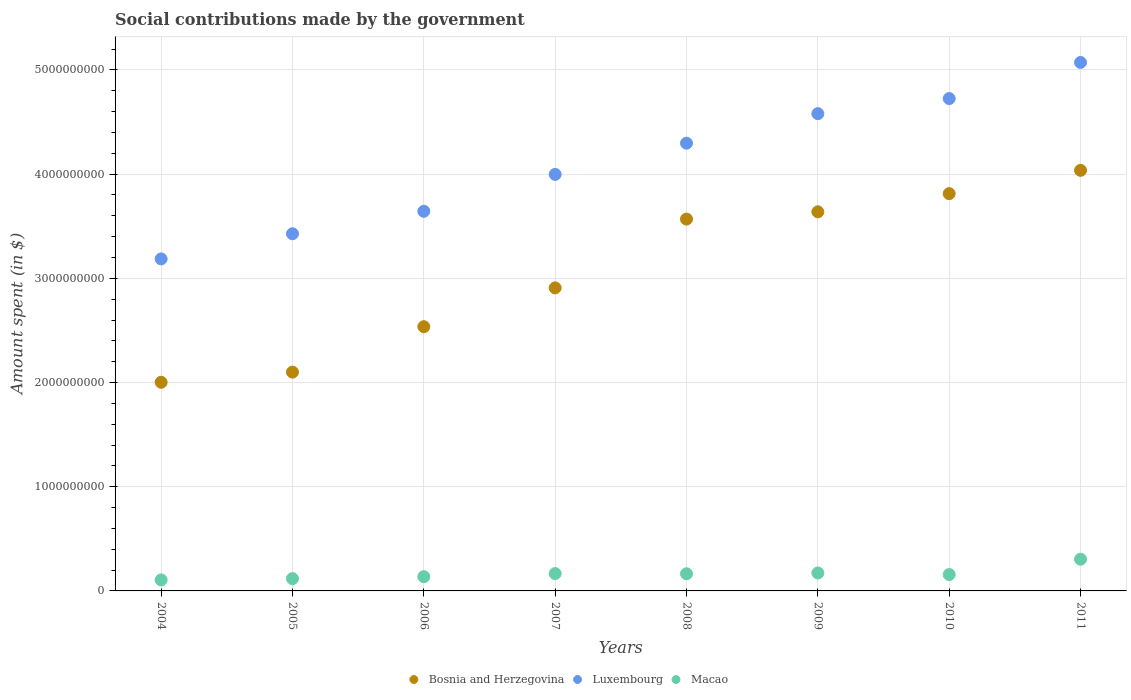Is the number of dotlines equal to the number of legend labels?
Keep it short and to the point. Yes. What is the amount spent on social contributions in Macao in 2011?
Provide a short and direct response. 3.05e+08. Across all years, what is the maximum amount spent on social contributions in Luxembourg?
Give a very brief answer. 5.07e+09. Across all years, what is the minimum amount spent on social contributions in Luxembourg?
Keep it short and to the point. 3.19e+09. In which year was the amount spent on social contributions in Bosnia and Herzegovina minimum?
Ensure brevity in your answer.  2004. What is the total amount spent on social contributions in Bosnia and Herzegovina in the graph?
Your answer should be compact. 2.46e+1. What is the difference between the amount spent on social contributions in Luxembourg in 2008 and that in 2009?
Your answer should be very brief. -2.83e+08. What is the difference between the amount spent on social contributions in Luxembourg in 2004 and the amount spent on social contributions in Macao in 2008?
Offer a terse response. 3.02e+09. What is the average amount spent on social contributions in Macao per year?
Your answer should be very brief. 1.66e+08. In the year 2004, what is the difference between the amount spent on social contributions in Macao and amount spent on social contributions in Luxembourg?
Provide a succinct answer. -3.08e+09. In how many years, is the amount spent on social contributions in Macao greater than 4000000000 $?
Provide a short and direct response. 0. What is the ratio of the amount spent on social contributions in Macao in 2007 to that in 2008?
Your response must be concise. 1.01. Is the difference between the amount spent on social contributions in Macao in 2007 and 2011 greater than the difference between the amount spent on social contributions in Luxembourg in 2007 and 2011?
Offer a terse response. Yes. What is the difference between the highest and the second highest amount spent on social contributions in Bosnia and Herzegovina?
Keep it short and to the point. 2.23e+08. What is the difference between the highest and the lowest amount spent on social contributions in Bosnia and Herzegovina?
Offer a terse response. 2.03e+09. Is the sum of the amount spent on social contributions in Bosnia and Herzegovina in 2005 and 2011 greater than the maximum amount spent on social contributions in Luxembourg across all years?
Provide a short and direct response. Yes. Does the amount spent on social contributions in Macao monotonically increase over the years?
Offer a very short reply. No. What is the difference between two consecutive major ticks on the Y-axis?
Keep it short and to the point. 1.00e+09. Are the values on the major ticks of Y-axis written in scientific E-notation?
Offer a terse response. No. Does the graph contain any zero values?
Keep it short and to the point. No. Does the graph contain grids?
Make the answer very short. Yes. How many legend labels are there?
Give a very brief answer. 3. How are the legend labels stacked?
Offer a very short reply. Horizontal. What is the title of the graph?
Give a very brief answer. Social contributions made by the government. What is the label or title of the X-axis?
Provide a short and direct response. Years. What is the label or title of the Y-axis?
Give a very brief answer. Amount spent (in $). What is the Amount spent (in $) of Bosnia and Herzegovina in 2004?
Offer a very short reply. 2.00e+09. What is the Amount spent (in $) in Luxembourg in 2004?
Provide a succinct answer. 3.19e+09. What is the Amount spent (in $) in Macao in 2004?
Provide a short and direct response. 1.06e+08. What is the Amount spent (in $) of Bosnia and Herzegovina in 2005?
Provide a short and direct response. 2.10e+09. What is the Amount spent (in $) of Luxembourg in 2005?
Your answer should be very brief. 3.43e+09. What is the Amount spent (in $) of Macao in 2005?
Give a very brief answer. 1.18e+08. What is the Amount spent (in $) of Bosnia and Herzegovina in 2006?
Make the answer very short. 2.54e+09. What is the Amount spent (in $) of Luxembourg in 2006?
Offer a very short reply. 3.64e+09. What is the Amount spent (in $) of Macao in 2006?
Your response must be concise. 1.37e+08. What is the Amount spent (in $) of Bosnia and Herzegovina in 2007?
Your answer should be very brief. 2.91e+09. What is the Amount spent (in $) of Luxembourg in 2007?
Provide a short and direct response. 4.00e+09. What is the Amount spent (in $) in Macao in 2007?
Offer a terse response. 1.66e+08. What is the Amount spent (in $) of Bosnia and Herzegovina in 2008?
Give a very brief answer. 3.57e+09. What is the Amount spent (in $) of Luxembourg in 2008?
Offer a very short reply. 4.30e+09. What is the Amount spent (in $) in Macao in 2008?
Keep it short and to the point. 1.65e+08. What is the Amount spent (in $) in Bosnia and Herzegovina in 2009?
Keep it short and to the point. 3.64e+09. What is the Amount spent (in $) of Luxembourg in 2009?
Your response must be concise. 4.58e+09. What is the Amount spent (in $) of Macao in 2009?
Ensure brevity in your answer.  1.72e+08. What is the Amount spent (in $) in Bosnia and Herzegovina in 2010?
Ensure brevity in your answer.  3.81e+09. What is the Amount spent (in $) of Luxembourg in 2010?
Your response must be concise. 4.73e+09. What is the Amount spent (in $) of Macao in 2010?
Provide a succinct answer. 1.57e+08. What is the Amount spent (in $) of Bosnia and Herzegovina in 2011?
Your answer should be very brief. 4.04e+09. What is the Amount spent (in $) in Luxembourg in 2011?
Provide a short and direct response. 5.07e+09. What is the Amount spent (in $) of Macao in 2011?
Your answer should be compact. 3.05e+08. Across all years, what is the maximum Amount spent (in $) of Bosnia and Herzegovina?
Your response must be concise. 4.04e+09. Across all years, what is the maximum Amount spent (in $) of Luxembourg?
Offer a terse response. 5.07e+09. Across all years, what is the maximum Amount spent (in $) in Macao?
Give a very brief answer. 3.05e+08. Across all years, what is the minimum Amount spent (in $) of Bosnia and Herzegovina?
Make the answer very short. 2.00e+09. Across all years, what is the minimum Amount spent (in $) of Luxembourg?
Your answer should be compact. 3.19e+09. Across all years, what is the minimum Amount spent (in $) of Macao?
Your answer should be compact. 1.06e+08. What is the total Amount spent (in $) of Bosnia and Herzegovina in the graph?
Offer a very short reply. 2.46e+1. What is the total Amount spent (in $) of Luxembourg in the graph?
Ensure brevity in your answer.  3.29e+1. What is the total Amount spent (in $) of Macao in the graph?
Provide a short and direct response. 1.33e+09. What is the difference between the Amount spent (in $) in Bosnia and Herzegovina in 2004 and that in 2005?
Give a very brief answer. -9.74e+07. What is the difference between the Amount spent (in $) of Luxembourg in 2004 and that in 2005?
Your response must be concise. -2.41e+08. What is the difference between the Amount spent (in $) of Macao in 2004 and that in 2005?
Keep it short and to the point. -1.25e+07. What is the difference between the Amount spent (in $) in Bosnia and Herzegovina in 2004 and that in 2006?
Your response must be concise. -5.34e+08. What is the difference between the Amount spent (in $) in Luxembourg in 2004 and that in 2006?
Offer a very short reply. -4.57e+08. What is the difference between the Amount spent (in $) of Macao in 2004 and that in 2006?
Provide a succinct answer. -3.15e+07. What is the difference between the Amount spent (in $) in Bosnia and Herzegovina in 2004 and that in 2007?
Provide a succinct answer. -9.06e+08. What is the difference between the Amount spent (in $) in Luxembourg in 2004 and that in 2007?
Ensure brevity in your answer.  -8.11e+08. What is the difference between the Amount spent (in $) of Macao in 2004 and that in 2007?
Your answer should be very brief. -6.09e+07. What is the difference between the Amount spent (in $) of Bosnia and Herzegovina in 2004 and that in 2008?
Offer a terse response. -1.57e+09. What is the difference between the Amount spent (in $) in Luxembourg in 2004 and that in 2008?
Provide a succinct answer. -1.11e+09. What is the difference between the Amount spent (in $) of Macao in 2004 and that in 2008?
Give a very brief answer. -5.90e+07. What is the difference between the Amount spent (in $) in Bosnia and Herzegovina in 2004 and that in 2009?
Your answer should be very brief. -1.64e+09. What is the difference between the Amount spent (in $) in Luxembourg in 2004 and that in 2009?
Offer a terse response. -1.39e+09. What is the difference between the Amount spent (in $) in Macao in 2004 and that in 2009?
Provide a succinct answer. -6.66e+07. What is the difference between the Amount spent (in $) of Bosnia and Herzegovina in 2004 and that in 2010?
Offer a terse response. -1.81e+09. What is the difference between the Amount spent (in $) of Luxembourg in 2004 and that in 2010?
Provide a succinct answer. -1.54e+09. What is the difference between the Amount spent (in $) of Macao in 2004 and that in 2010?
Your answer should be compact. -5.16e+07. What is the difference between the Amount spent (in $) in Bosnia and Herzegovina in 2004 and that in 2011?
Your answer should be compact. -2.03e+09. What is the difference between the Amount spent (in $) in Luxembourg in 2004 and that in 2011?
Offer a very short reply. -1.89e+09. What is the difference between the Amount spent (in $) of Macao in 2004 and that in 2011?
Your response must be concise. -1.99e+08. What is the difference between the Amount spent (in $) in Bosnia and Herzegovina in 2005 and that in 2006?
Provide a short and direct response. -4.36e+08. What is the difference between the Amount spent (in $) of Luxembourg in 2005 and that in 2006?
Provide a short and direct response. -2.16e+08. What is the difference between the Amount spent (in $) of Macao in 2005 and that in 2006?
Offer a very short reply. -1.90e+07. What is the difference between the Amount spent (in $) in Bosnia and Herzegovina in 2005 and that in 2007?
Your response must be concise. -8.09e+08. What is the difference between the Amount spent (in $) in Luxembourg in 2005 and that in 2007?
Provide a succinct answer. -5.70e+08. What is the difference between the Amount spent (in $) in Macao in 2005 and that in 2007?
Your answer should be very brief. -4.84e+07. What is the difference between the Amount spent (in $) in Bosnia and Herzegovina in 2005 and that in 2008?
Ensure brevity in your answer.  -1.47e+09. What is the difference between the Amount spent (in $) in Luxembourg in 2005 and that in 2008?
Make the answer very short. -8.69e+08. What is the difference between the Amount spent (in $) in Macao in 2005 and that in 2008?
Provide a succinct answer. -4.65e+07. What is the difference between the Amount spent (in $) in Bosnia and Herzegovina in 2005 and that in 2009?
Offer a terse response. -1.54e+09. What is the difference between the Amount spent (in $) of Luxembourg in 2005 and that in 2009?
Make the answer very short. -1.15e+09. What is the difference between the Amount spent (in $) of Macao in 2005 and that in 2009?
Offer a terse response. -5.42e+07. What is the difference between the Amount spent (in $) in Bosnia and Herzegovina in 2005 and that in 2010?
Keep it short and to the point. -1.71e+09. What is the difference between the Amount spent (in $) of Luxembourg in 2005 and that in 2010?
Provide a succinct answer. -1.30e+09. What is the difference between the Amount spent (in $) in Macao in 2005 and that in 2010?
Your response must be concise. -3.92e+07. What is the difference between the Amount spent (in $) in Bosnia and Herzegovina in 2005 and that in 2011?
Give a very brief answer. -1.94e+09. What is the difference between the Amount spent (in $) of Luxembourg in 2005 and that in 2011?
Give a very brief answer. -1.64e+09. What is the difference between the Amount spent (in $) of Macao in 2005 and that in 2011?
Give a very brief answer. -1.87e+08. What is the difference between the Amount spent (in $) of Bosnia and Herzegovina in 2006 and that in 2007?
Offer a terse response. -3.73e+08. What is the difference between the Amount spent (in $) in Luxembourg in 2006 and that in 2007?
Provide a short and direct response. -3.54e+08. What is the difference between the Amount spent (in $) of Macao in 2006 and that in 2007?
Ensure brevity in your answer.  -2.94e+07. What is the difference between the Amount spent (in $) in Bosnia and Herzegovina in 2006 and that in 2008?
Provide a short and direct response. -1.03e+09. What is the difference between the Amount spent (in $) of Luxembourg in 2006 and that in 2008?
Offer a terse response. -6.53e+08. What is the difference between the Amount spent (in $) in Macao in 2006 and that in 2008?
Your answer should be compact. -2.75e+07. What is the difference between the Amount spent (in $) of Bosnia and Herzegovina in 2006 and that in 2009?
Your answer should be very brief. -1.10e+09. What is the difference between the Amount spent (in $) of Luxembourg in 2006 and that in 2009?
Your answer should be compact. -9.37e+08. What is the difference between the Amount spent (in $) of Macao in 2006 and that in 2009?
Provide a succinct answer. -3.52e+07. What is the difference between the Amount spent (in $) of Bosnia and Herzegovina in 2006 and that in 2010?
Keep it short and to the point. -1.28e+09. What is the difference between the Amount spent (in $) of Luxembourg in 2006 and that in 2010?
Offer a very short reply. -1.08e+09. What is the difference between the Amount spent (in $) of Macao in 2006 and that in 2010?
Offer a very short reply. -2.02e+07. What is the difference between the Amount spent (in $) of Bosnia and Herzegovina in 2006 and that in 2011?
Make the answer very short. -1.50e+09. What is the difference between the Amount spent (in $) in Luxembourg in 2006 and that in 2011?
Make the answer very short. -1.43e+09. What is the difference between the Amount spent (in $) in Macao in 2006 and that in 2011?
Ensure brevity in your answer.  -1.68e+08. What is the difference between the Amount spent (in $) in Bosnia and Herzegovina in 2007 and that in 2008?
Your answer should be very brief. -6.60e+08. What is the difference between the Amount spent (in $) of Luxembourg in 2007 and that in 2008?
Offer a terse response. -2.99e+08. What is the difference between the Amount spent (in $) of Macao in 2007 and that in 2008?
Your response must be concise. 1.84e+06. What is the difference between the Amount spent (in $) in Bosnia and Herzegovina in 2007 and that in 2009?
Offer a very short reply. -7.30e+08. What is the difference between the Amount spent (in $) in Luxembourg in 2007 and that in 2009?
Offer a terse response. -5.83e+08. What is the difference between the Amount spent (in $) of Macao in 2007 and that in 2009?
Provide a short and direct response. -5.79e+06. What is the difference between the Amount spent (in $) in Bosnia and Herzegovina in 2007 and that in 2010?
Provide a short and direct response. -9.04e+08. What is the difference between the Amount spent (in $) of Luxembourg in 2007 and that in 2010?
Provide a short and direct response. -7.28e+08. What is the difference between the Amount spent (in $) in Macao in 2007 and that in 2010?
Your answer should be compact. 9.21e+06. What is the difference between the Amount spent (in $) of Bosnia and Herzegovina in 2007 and that in 2011?
Give a very brief answer. -1.13e+09. What is the difference between the Amount spent (in $) in Luxembourg in 2007 and that in 2011?
Keep it short and to the point. -1.07e+09. What is the difference between the Amount spent (in $) of Macao in 2007 and that in 2011?
Give a very brief answer. -1.38e+08. What is the difference between the Amount spent (in $) of Bosnia and Herzegovina in 2008 and that in 2009?
Your response must be concise. -6.99e+07. What is the difference between the Amount spent (in $) of Luxembourg in 2008 and that in 2009?
Offer a very short reply. -2.83e+08. What is the difference between the Amount spent (in $) of Macao in 2008 and that in 2009?
Make the answer very short. -7.63e+06. What is the difference between the Amount spent (in $) in Bosnia and Herzegovina in 2008 and that in 2010?
Provide a short and direct response. -2.44e+08. What is the difference between the Amount spent (in $) in Luxembourg in 2008 and that in 2010?
Offer a very short reply. -4.28e+08. What is the difference between the Amount spent (in $) of Macao in 2008 and that in 2010?
Keep it short and to the point. 7.37e+06. What is the difference between the Amount spent (in $) of Bosnia and Herzegovina in 2008 and that in 2011?
Your answer should be compact. -4.68e+08. What is the difference between the Amount spent (in $) of Luxembourg in 2008 and that in 2011?
Make the answer very short. -7.75e+08. What is the difference between the Amount spent (in $) of Macao in 2008 and that in 2011?
Keep it short and to the point. -1.40e+08. What is the difference between the Amount spent (in $) of Bosnia and Herzegovina in 2009 and that in 2010?
Offer a terse response. -1.75e+08. What is the difference between the Amount spent (in $) in Luxembourg in 2009 and that in 2010?
Your answer should be very brief. -1.45e+08. What is the difference between the Amount spent (in $) in Macao in 2009 and that in 2010?
Ensure brevity in your answer.  1.50e+07. What is the difference between the Amount spent (in $) of Bosnia and Herzegovina in 2009 and that in 2011?
Give a very brief answer. -3.98e+08. What is the difference between the Amount spent (in $) of Luxembourg in 2009 and that in 2011?
Provide a succinct answer. -4.92e+08. What is the difference between the Amount spent (in $) of Macao in 2009 and that in 2011?
Make the answer very short. -1.32e+08. What is the difference between the Amount spent (in $) of Bosnia and Herzegovina in 2010 and that in 2011?
Provide a short and direct response. -2.23e+08. What is the difference between the Amount spent (in $) in Luxembourg in 2010 and that in 2011?
Make the answer very short. -3.47e+08. What is the difference between the Amount spent (in $) in Macao in 2010 and that in 2011?
Make the answer very short. -1.47e+08. What is the difference between the Amount spent (in $) of Bosnia and Herzegovina in 2004 and the Amount spent (in $) of Luxembourg in 2005?
Provide a succinct answer. -1.43e+09. What is the difference between the Amount spent (in $) in Bosnia and Herzegovina in 2004 and the Amount spent (in $) in Macao in 2005?
Offer a very short reply. 1.88e+09. What is the difference between the Amount spent (in $) of Luxembourg in 2004 and the Amount spent (in $) of Macao in 2005?
Ensure brevity in your answer.  3.07e+09. What is the difference between the Amount spent (in $) of Bosnia and Herzegovina in 2004 and the Amount spent (in $) of Luxembourg in 2006?
Your answer should be compact. -1.64e+09. What is the difference between the Amount spent (in $) of Bosnia and Herzegovina in 2004 and the Amount spent (in $) of Macao in 2006?
Offer a very short reply. 1.87e+09. What is the difference between the Amount spent (in $) of Luxembourg in 2004 and the Amount spent (in $) of Macao in 2006?
Your response must be concise. 3.05e+09. What is the difference between the Amount spent (in $) of Bosnia and Herzegovina in 2004 and the Amount spent (in $) of Luxembourg in 2007?
Your answer should be compact. -2.00e+09. What is the difference between the Amount spent (in $) of Bosnia and Herzegovina in 2004 and the Amount spent (in $) of Macao in 2007?
Your answer should be very brief. 1.84e+09. What is the difference between the Amount spent (in $) in Luxembourg in 2004 and the Amount spent (in $) in Macao in 2007?
Offer a very short reply. 3.02e+09. What is the difference between the Amount spent (in $) in Bosnia and Herzegovina in 2004 and the Amount spent (in $) in Luxembourg in 2008?
Offer a terse response. -2.29e+09. What is the difference between the Amount spent (in $) of Bosnia and Herzegovina in 2004 and the Amount spent (in $) of Macao in 2008?
Provide a succinct answer. 1.84e+09. What is the difference between the Amount spent (in $) in Luxembourg in 2004 and the Amount spent (in $) in Macao in 2008?
Provide a succinct answer. 3.02e+09. What is the difference between the Amount spent (in $) of Bosnia and Herzegovina in 2004 and the Amount spent (in $) of Luxembourg in 2009?
Keep it short and to the point. -2.58e+09. What is the difference between the Amount spent (in $) in Bosnia and Herzegovina in 2004 and the Amount spent (in $) in Macao in 2009?
Your answer should be compact. 1.83e+09. What is the difference between the Amount spent (in $) of Luxembourg in 2004 and the Amount spent (in $) of Macao in 2009?
Your response must be concise. 3.01e+09. What is the difference between the Amount spent (in $) of Bosnia and Herzegovina in 2004 and the Amount spent (in $) of Luxembourg in 2010?
Provide a succinct answer. -2.72e+09. What is the difference between the Amount spent (in $) in Bosnia and Herzegovina in 2004 and the Amount spent (in $) in Macao in 2010?
Ensure brevity in your answer.  1.85e+09. What is the difference between the Amount spent (in $) in Luxembourg in 2004 and the Amount spent (in $) in Macao in 2010?
Offer a terse response. 3.03e+09. What is the difference between the Amount spent (in $) in Bosnia and Herzegovina in 2004 and the Amount spent (in $) in Luxembourg in 2011?
Make the answer very short. -3.07e+09. What is the difference between the Amount spent (in $) in Bosnia and Herzegovina in 2004 and the Amount spent (in $) in Macao in 2011?
Offer a very short reply. 1.70e+09. What is the difference between the Amount spent (in $) of Luxembourg in 2004 and the Amount spent (in $) of Macao in 2011?
Make the answer very short. 2.88e+09. What is the difference between the Amount spent (in $) in Bosnia and Herzegovina in 2005 and the Amount spent (in $) in Luxembourg in 2006?
Make the answer very short. -1.54e+09. What is the difference between the Amount spent (in $) in Bosnia and Herzegovina in 2005 and the Amount spent (in $) in Macao in 2006?
Provide a succinct answer. 1.96e+09. What is the difference between the Amount spent (in $) of Luxembourg in 2005 and the Amount spent (in $) of Macao in 2006?
Your answer should be compact. 3.29e+09. What is the difference between the Amount spent (in $) of Bosnia and Herzegovina in 2005 and the Amount spent (in $) of Luxembourg in 2007?
Provide a short and direct response. -1.90e+09. What is the difference between the Amount spent (in $) of Bosnia and Herzegovina in 2005 and the Amount spent (in $) of Macao in 2007?
Your answer should be very brief. 1.93e+09. What is the difference between the Amount spent (in $) in Luxembourg in 2005 and the Amount spent (in $) in Macao in 2007?
Make the answer very short. 3.26e+09. What is the difference between the Amount spent (in $) in Bosnia and Herzegovina in 2005 and the Amount spent (in $) in Luxembourg in 2008?
Ensure brevity in your answer.  -2.20e+09. What is the difference between the Amount spent (in $) in Bosnia and Herzegovina in 2005 and the Amount spent (in $) in Macao in 2008?
Your answer should be compact. 1.94e+09. What is the difference between the Amount spent (in $) of Luxembourg in 2005 and the Amount spent (in $) of Macao in 2008?
Your answer should be compact. 3.26e+09. What is the difference between the Amount spent (in $) in Bosnia and Herzegovina in 2005 and the Amount spent (in $) in Luxembourg in 2009?
Your answer should be very brief. -2.48e+09. What is the difference between the Amount spent (in $) of Bosnia and Herzegovina in 2005 and the Amount spent (in $) of Macao in 2009?
Provide a succinct answer. 1.93e+09. What is the difference between the Amount spent (in $) of Luxembourg in 2005 and the Amount spent (in $) of Macao in 2009?
Provide a succinct answer. 3.26e+09. What is the difference between the Amount spent (in $) in Bosnia and Herzegovina in 2005 and the Amount spent (in $) in Luxembourg in 2010?
Provide a short and direct response. -2.63e+09. What is the difference between the Amount spent (in $) in Bosnia and Herzegovina in 2005 and the Amount spent (in $) in Macao in 2010?
Ensure brevity in your answer.  1.94e+09. What is the difference between the Amount spent (in $) of Luxembourg in 2005 and the Amount spent (in $) of Macao in 2010?
Offer a terse response. 3.27e+09. What is the difference between the Amount spent (in $) in Bosnia and Herzegovina in 2005 and the Amount spent (in $) in Luxembourg in 2011?
Provide a short and direct response. -2.97e+09. What is the difference between the Amount spent (in $) of Bosnia and Herzegovina in 2005 and the Amount spent (in $) of Macao in 2011?
Give a very brief answer. 1.80e+09. What is the difference between the Amount spent (in $) in Luxembourg in 2005 and the Amount spent (in $) in Macao in 2011?
Offer a terse response. 3.12e+09. What is the difference between the Amount spent (in $) in Bosnia and Herzegovina in 2006 and the Amount spent (in $) in Luxembourg in 2007?
Your answer should be very brief. -1.46e+09. What is the difference between the Amount spent (in $) of Bosnia and Herzegovina in 2006 and the Amount spent (in $) of Macao in 2007?
Offer a very short reply. 2.37e+09. What is the difference between the Amount spent (in $) in Luxembourg in 2006 and the Amount spent (in $) in Macao in 2007?
Ensure brevity in your answer.  3.48e+09. What is the difference between the Amount spent (in $) in Bosnia and Herzegovina in 2006 and the Amount spent (in $) in Luxembourg in 2008?
Provide a succinct answer. -1.76e+09. What is the difference between the Amount spent (in $) in Bosnia and Herzegovina in 2006 and the Amount spent (in $) in Macao in 2008?
Ensure brevity in your answer.  2.37e+09. What is the difference between the Amount spent (in $) of Luxembourg in 2006 and the Amount spent (in $) of Macao in 2008?
Your answer should be compact. 3.48e+09. What is the difference between the Amount spent (in $) of Bosnia and Herzegovina in 2006 and the Amount spent (in $) of Luxembourg in 2009?
Provide a succinct answer. -2.04e+09. What is the difference between the Amount spent (in $) in Bosnia and Herzegovina in 2006 and the Amount spent (in $) in Macao in 2009?
Offer a very short reply. 2.36e+09. What is the difference between the Amount spent (in $) of Luxembourg in 2006 and the Amount spent (in $) of Macao in 2009?
Offer a very short reply. 3.47e+09. What is the difference between the Amount spent (in $) of Bosnia and Herzegovina in 2006 and the Amount spent (in $) of Luxembourg in 2010?
Your answer should be compact. -2.19e+09. What is the difference between the Amount spent (in $) in Bosnia and Herzegovina in 2006 and the Amount spent (in $) in Macao in 2010?
Make the answer very short. 2.38e+09. What is the difference between the Amount spent (in $) in Luxembourg in 2006 and the Amount spent (in $) in Macao in 2010?
Offer a very short reply. 3.49e+09. What is the difference between the Amount spent (in $) of Bosnia and Herzegovina in 2006 and the Amount spent (in $) of Luxembourg in 2011?
Your response must be concise. -2.54e+09. What is the difference between the Amount spent (in $) of Bosnia and Herzegovina in 2006 and the Amount spent (in $) of Macao in 2011?
Give a very brief answer. 2.23e+09. What is the difference between the Amount spent (in $) of Luxembourg in 2006 and the Amount spent (in $) of Macao in 2011?
Offer a terse response. 3.34e+09. What is the difference between the Amount spent (in $) in Bosnia and Herzegovina in 2007 and the Amount spent (in $) in Luxembourg in 2008?
Your answer should be very brief. -1.39e+09. What is the difference between the Amount spent (in $) in Bosnia and Herzegovina in 2007 and the Amount spent (in $) in Macao in 2008?
Provide a short and direct response. 2.74e+09. What is the difference between the Amount spent (in $) of Luxembourg in 2007 and the Amount spent (in $) of Macao in 2008?
Provide a short and direct response. 3.83e+09. What is the difference between the Amount spent (in $) of Bosnia and Herzegovina in 2007 and the Amount spent (in $) of Luxembourg in 2009?
Your answer should be compact. -1.67e+09. What is the difference between the Amount spent (in $) in Bosnia and Herzegovina in 2007 and the Amount spent (in $) in Macao in 2009?
Offer a terse response. 2.74e+09. What is the difference between the Amount spent (in $) in Luxembourg in 2007 and the Amount spent (in $) in Macao in 2009?
Your response must be concise. 3.83e+09. What is the difference between the Amount spent (in $) of Bosnia and Herzegovina in 2007 and the Amount spent (in $) of Luxembourg in 2010?
Keep it short and to the point. -1.82e+09. What is the difference between the Amount spent (in $) in Bosnia and Herzegovina in 2007 and the Amount spent (in $) in Macao in 2010?
Your answer should be very brief. 2.75e+09. What is the difference between the Amount spent (in $) of Luxembourg in 2007 and the Amount spent (in $) of Macao in 2010?
Offer a very short reply. 3.84e+09. What is the difference between the Amount spent (in $) in Bosnia and Herzegovina in 2007 and the Amount spent (in $) in Luxembourg in 2011?
Your response must be concise. -2.16e+09. What is the difference between the Amount spent (in $) of Bosnia and Herzegovina in 2007 and the Amount spent (in $) of Macao in 2011?
Make the answer very short. 2.60e+09. What is the difference between the Amount spent (in $) in Luxembourg in 2007 and the Amount spent (in $) in Macao in 2011?
Keep it short and to the point. 3.69e+09. What is the difference between the Amount spent (in $) of Bosnia and Herzegovina in 2008 and the Amount spent (in $) of Luxembourg in 2009?
Your answer should be very brief. -1.01e+09. What is the difference between the Amount spent (in $) of Bosnia and Herzegovina in 2008 and the Amount spent (in $) of Macao in 2009?
Give a very brief answer. 3.40e+09. What is the difference between the Amount spent (in $) of Luxembourg in 2008 and the Amount spent (in $) of Macao in 2009?
Offer a terse response. 4.12e+09. What is the difference between the Amount spent (in $) of Bosnia and Herzegovina in 2008 and the Amount spent (in $) of Luxembourg in 2010?
Make the answer very short. -1.16e+09. What is the difference between the Amount spent (in $) of Bosnia and Herzegovina in 2008 and the Amount spent (in $) of Macao in 2010?
Your response must be concise. 3.41e+09. What is the difference between the Amount spent (in $) of Luxembourg in 2008 and the Amount spent (in $) of Macao in 2010?
Give a very brief answer. 4.14e+09. What is the difference between the Amount spent (in $) of Bosnia and Herzegovina in 2008 and the Amount spent (in $) of Luxembourg in 2011?
Give a very brief answer. -1.50e+09. What is the difference between the Amount spent (in $) of Bosnia and Herzegovina in 2008 and the Amount spent (in $) of Macao in 2011?
Ensure brevity in your answer.  3.26e+09. What is the difference between the Amount spent (in $) of Luxembourg in 2008 and the Amount spent (in $) of Macao in 2011?
Give a very brief answer. 3.99e+09. What is the difference between the Amount spent (in $) in Bosnia and Herzegovina in 2009 and the Amount spent (in $) in Luxembourg in 2010?
Give a very brief answer. -1.09e+09. What is the difference between the Amount spent (in $) in Bosnia and Herzegovina in 2009 and the Amount spent (in $) in Macao in 2010?
Keep it short and to the point. 3.48e+09. What is the difference between the Amount spent (in $) in Luxembourg in 2009 and the Amount spent (in $) in Macao in 2010?
Your answer should be very brief. 4.42e+09. What is the difference between the Amount spent (in $) in Bosnia and Herzegovina in 2009 and the Amount spent (in $) in Luxembourg in 2011?
Give a very brief answer. -1.43e+09. What is the difference between the Amount spent (in $) of Bosnia and Herzegovina in 2009 and the Amount spent (in $) of Macao in 2011?
Make the answer very short. 3.33e+09. What is the difference between the Amount spent (in $) in Luxembourg in 2009 and the Amount spent (in $) in Macao in 2011?
Offer a very short reply. 4.28e+09. What is the difference between the Amount spent (in $) in Bosnia and Herzegovina in 2010 and the Amount spent (in $) in Luxembourg in 2011?
Ensure brevity in your answer.  -1.26e+09. What is the difference between the Amount spent (in $) of Bosnia and Herzegovina in 2010 and the Amount spent (in $) of Macao in 2011?
Provide a short and direct response. 3.51e+09. What is the difference between the Amount spent (in $) of Luxembourg in 2010 and the Amount spent (in $) of Macao in 2011?
Provide a short and direct response. 4.42e+09. What is the average Amount spent (in $) in Bosnia and Herzegovina per year?
Keep it short and to the point. 3.08e+09. What is the average Amount spent (in $) of Luxembourg per year?
Your answer should be compact. 4.12e+09. What is the average Amount spent (in $) in Macao per year?
Give a very brief answer. 1.66e+08. In the year 2004, what is the difference between the Amount spent (in $) of Bosnia and Herzegovina and Amount spent (in $) of Luxembourg?
Your response must be concise. -1.18e+09. In the year 2004, what is the difference between the Amount spent (in $) in Bosnia and Herzegovina and Amount spent (in $) in Macao?
Your answer should be very brief. 1.90e+09. In the year 2004, what is the difference between the Amount spent (in $) in Luxembourg and Amount spent (in $) in Macao?
Offer a very short reply. 3.08e+09. In the year 2005, what is the difference between the Amount spent (in $) of Bosnia and Herzegovina and Amount spent (in $) of Luxembourg?
Your answer should be very brief. -1.33e+09. In the year 2005, what is the difference between the Amount spent (in $) of Bosnia and Herzegovina and Amount spent (in $) of Macao?
Your response must be concise. 1.98e+09. In the year 2005, what is the difference between the Amount spent (in $) of Luxembourg and Amount spent (in $) of Macao?
Your response must be concise. 3.31e+09. In the year 2006, what is the difference between the Amount spent (in $) of Bosnia and Herzegovina and Amount spent (in $) of Luxembourg?
Your answer should be compact. -1.11e+09. In the year 2006, what is the difference between the Amount spent (in $) of Bosnia and Herzegovina and Amount spent (in $) of Macao?
Your answer should be very brief. 2.40e+09. In the year 2006, what is the difference between the Amount spent (in $) of Luxembourg and Amount spent (in $) of Macao?
Provide a short and direct response. 3.51e+09. In the year 2007, what is the difference between the Amount spent (in $) in Bosnia and Herzegovina and Amount spent (in $) in Luxembourg?
Provide a short and direct response. -1.09e+09. In the year 2007, what is the difference between the Amount spent (in $) in Bosnia and Herzegovina and Amount spent (in $) in Macao?
Give a very brief answer. 2.74e+09. In the year 2007, what is the difference between the Amount spent (in $) of Luxembourg and Amount spent (in $) of Macao?
Keep it short and to the point. 3.83e+09. In the year 2008, what is the difference between the Amount spent (in $) in Bosnia and Herzegovina and Amount spent (in $) in Luxembourg?
Your answer should be very brief. -7.28e+08. In the year 2008, what is the difference between the Amount spent (in $) in Bosnia and Herzegovina and Amount spent (in $) in Macao?
Offer a very short reply. 3.40e+09. In the year 2008, what is the difference between the Amount spent (in $) of Luxembourg and Amount spent (in $) of Macao?
Offer a terse response. 4.13e+09. In the year 2009, what is the difference between the Amount spent (in $) of Bosnia and Herzegovina and Amount spent (in $) of Luxembourg?
Offer a terse response. -9.42e+08. In the year 2009, what is the difference between the Amount spent (in $) in Bosnia and Herzegovina and Amount spent (in $) in Macao?
Your answer should be very brief. 3.47e+09. In the year 2009, what is the difference between the Amount spent (in $) of Luxembourg and Amount spent (in $) of Macao?
Your answer should be compact. 4.41e+09. In the year 2010, what is the difference between the Amount spent (in $) in Bosnia and Herzegovina and Amount spent (in $) in Luxembourg?
Offer a terse response. -9.12e+08. In the year 2010, what is the difference between the Amount spent (in $) in Bosnia and Herzegovina and Amount spent (in $) in Macao?
Your answer should be compact. 3.66e+09. In the year 2010, what is the difference between the Amount spent (in $) in Luxembourg and Amount spent (in $) in Macao?
Your response must be concise. 4.57e+09. In the year 2011, what is the difference between the Amount spent (in $) in Bosnia and Herzegovina and Amount spent (in $) in Luxembourg?
Your response must be concise. -1.04e+09. In the year 2011, what is the difference between the Amount spent (in $) of Bosnia and Herzegovina and Amount spent (in $) of Macao?
Offer a terse response. 3.73e+09. In the year 2011, what is the difference between the Amount spent (in $) in Luxembourg and Amount spent (in $) in Macao?
Give a very brief answer. 4.77e+09. What is the ratio of the Amount spent (in $) in Bosnia and Herzegovina in 2004 to that in 2005?
Your answer should be compact. 0.95. What is the ratio of the Amount spent (in $) in Luxembourg in 2004 to that in 2005?
Provide a succinct answer. 0.93. What is the ratio of the Amount spent (in $) of Macao in 2004 to that in 2005?
Your response must be concise. 0.89. What is the ratio of the Amount spent (in $) of Bosnia and Herzegovina in 2004 to that in 2006?
Your answer should be compact. 0.79. What is the ratio of the Amount spent (in $) of Luxembourg in 2004 to that in 2006?
Your response must be concise. 0.87. What is the ratio of the Amount spent (in $) in Macao in 2004 to that in 2006?
Offer a very short reply. 0.77. What is the ratio of the Amount spent (in $) in Bosnia and Herzegovina in 2004 to that in 2007?
Your answer should be very brief. 0.69. What is the ratio of the Amount spent (in $) of Luxembourg in 2004 to that in 2007?
Offer a terse response. 0.8. What is the ratio of the Amount spent (in $) of Macao in 2004 to that in 2007?
Your answer should be compact. 0.63. What is the ratio of the Amount spent (in $) in Bosnia and Herzegovina in 2004 to that in 2008?
Keep it short and to the point. 0.56. What is the ratio of the Amount spent (in $) of Luxembourg in 2004 to that in 2008?
Offer a very short reply. 0.74. What is the ratio of the Amount spent (in $) in Macao in 2004 to that in 2008?
Provide a succinct answer. 0.64. What is the ratio of the Amount spent (in $) of Bosnia and Herzegovina in 2004 to that in 2009?
Provide a succinct answer. 0.55. What is the ratio of the Amount spent (in $) of Luxembourg in 2004 to that in 2009?
Offer a terse response. 0.7. What is the ratio of the Amount spent (in $) in Macao in 2004 to that in 2009?
Provide a short and direct response. 0.61. What is the ratio of the Amount spent (in $) in Bosnia and Herzegovina in 2004 to that in 2010?
Provide a short and direct response. 0.53. What is the ratio of the Amount spent (in $) in Luxembourg in 2004 to that in 2010?
Provide a succinct answer. 0.67. What is the ratio of the Amount spent (in $) of Macao in 2004 to that in 2010?
Your answer should be compact. 0.67. What is the ratio of the Amount spent (in $) in Bosnia and Herzegovina in 2004 to that in 2011?
Ensure brevity in your answer.  0.5. What is the ratio of the Amount spent (in $) in Luxembourg in 2004 to that in 2011?
Your answer should be very brief. 0.63. What is the ratio of the Amount spent (in $) of Macao in 2004 to that in 2011?
Offer a very short reply. 0.35. What is the ratio of the Amount spent (in $) of Bosnia and Herzegovina in 2005 to that in 2006?
Ensure brevity in your answer.  0.83. What is the ratio of the Amount spent (in $) of Luxembourg in 2005 to that in 2006?
Your response must be concise. 0.94. What is the ratio of the Amount spent (in $) in Macao in 2005 to that in 2006?
Your answer should be compact. 0.86. What is the ratio of the Amount spent (in $) of Bosnia and Herzegovina in 2005 to that in 2007?
Your response must be concise. 0.72. What is the ratio of the Amount spent (in $) of Luxembourg in 2005 to that in 2007?
Provide a succinct answer. 0.86. What is the ratio of the Amount spent (in $) of Macao in 2005 to that in 2007?
Your answer should be very brief. 0.71. What is the ratio of the Amount spent (in $) of Bosnia and Herzegovina in 2005 to that in 2008?
Keep it short and to the point. 0.59. What is the ratio of the Amount spent (in $) of Luxembourg in 2005 to that in 2008?
Ensure brevity in your answer.  0.8. What is the ratio of the Amount spent (in $) in Macao in 2005 to that in 2008?
Make the answer very short. 0.72. What is the ratio of the Amount spent (in $) in Bosnia and Herzegovina in 2005 to that in 2009?
Your answer should be compact. 0.58. What is the ratio of the Amount spent (in $) in Luxembourg in 2005 to that in 2009?
Give a very brief answer. 0.75. What is the ratio of the Amount spent (in $) of Macao in 2005 to that in 2009?
Offer a very short reply. 0.69. What is the ratio of the Amount spent (in $) of Bosnia and Herzegovina in 2005 to that in 2010?
Make the answer very short. 0.55. What is the ratio of the Amount spent (in $) in Luxembourg in 2005 to that in 2010?
Ensure brevity in your answer.  0.73. What is the ratio of the Amount spent (in $) in Macao in 2005 to that in 2010?
Your response must be concise. 0.75. What is the ratio of the Amount spent (in $) of Bosnia and Herzegovina in 2005 to that in 2011?
Provide a short and direct response. 0.52. What is the ratio of the Amount spent (in $) in Luxembourg in 2005 to that in 2011?
Offer a terse response. 0.68. What is the ratio of the Amount spent (in $) in Macao in 2005 to that in 2011?
Keep it short and to the point. 0.39. What is the ratio of the Amount spent (in $) of Bosnia and Herzegovina in 2006 to that in 2007?
Give a very brief answer. 0.87. What is the ratio of the Amount spent (in $) in Luxembourg in 2006 to that in 2007?
Provide a short and direct response. 0.91. What is the ratio of the Amount spent (in $) in Macao in 2006 to that in 2007?
Make the answer very short. 0.82. What is the ratio of the Amount spent (in $) of Bosnia and Herzegovina in 2006 to that in 2008?
Keep it short and to the point. 0.71. What is the ratio of the Amount spent (in $) in Luxembourg in 2006 to that in 2008?
Keep it short and to the point. 0.85. What is the ratio of the Amount spent (in $) in Macao in 2006 to that in 2008?
Provide a short and direct response. 0.83. What is the ratio of the Amount spent (in $) in Bosnia and Herzegovina in 2006 to that in 2009?
Make the answer very short. 0.7. What is the ratio of the Amount spent (in $) of Luxembourg in 2006 to that in 2009?
Make the answer very short. 0.8. What is the ratio of the Amount spent (in $) in Macao in 2006 to that in 2009?
Your response must be concise. 0.8. What is the ratio of the Amount spent (in $) in Bosnia and Herzegovina in 2006 to that in 2010?
Offer a very short reply. 0.67. What is the ratio of the Amount spent (in $) of Luxembourg in 2006 to that in 2010?
Keep it short and to the point. 0.77. What is the ratio of the Amount spent (in $) in Macao in 2006 to that in 2010?
Offer a very short reply. 0.87. What is the ratio of the Amount spent (in $) in Bosnia and Herzegovina in 2006 to that in 2011?
Make the answer very short. 0.63. What is the ratio of the Amount spent (in $) of Luxembourg in 2006 to that in 2011?
Your response must be concise. 0.72. What is the ratio of the Amount spent (in $) in Macao in 2006 to that in 2011?
Keep it short and to the point. 0.45. What is the ratio of the Amount spent (in $) in Bosnia and Herzegovina in 2007 to that in 2008?
Your response must be concise. 0.82. What is the ratio of the Amount spent (in $) in Luxembourg in 2007 to that in 2008?
Your answer should be very brief. 0.93. What is the ratio of the Amount spent (in $) of Macao in 2007 to that in 2008?
Ensure brevity in your answer.  1.01. What is the ratio of the Amount spent (in $) of Bosnia and Herzegovina in 2007 to that in 2009?
Keep it short and to the point. 0.8. What is the ratio of the Amount spent (in $) in Luxembourg in 2007 to that in 2009?
Your answer should be compact. 0.87. What is the ratio of the Amount spent (in $) of Macao in 2007 to that in 2009?
Your response must be concise. 0.97. What is the ratio of the Amount spent (in $) of Bosnia and Herzegovina in 2007 to that in 2010?
Keep it short and to the point. 0.76. What is the ratio of the Amount spent (in $) in Luxembourg in 2007 to that in 2010?
Your answer should be very brief. 0.85. What is the ratio of the Amount spent (in $) in Macao in 2007 to that in 2010?
Provide a succinct answer. 1.06. What is the ratio of the Amount spent (in $) of Bosnia and Herzegovina in 2007 to that in 2011?
Provide a succinct answer. 0.72. What is the ratio of the Amount spent (in $) in Luxembourg in 2007 to that in 2011?
Give a very brief answer. 0.79. What is the ratio of the Amount spent (in $) of Macao in 2007 to that in 2011?
Ensure brevity in your answer.  0.55. What is the ratio of the Amount spent (in $) in Bosnia and Herzegovina in 2008 to that in 2009?
Offer a terse response. 0.98. What is the ratio of the Amount spent (in $) of Luxembourg in 2008 to that in 2009?
Give a very brief answer. 0.94. What is the ratio of the Amount spent (in $) in Macao in 2008 to that in 2009?
Your answer should be compact. 0.96. What is the ratio of the Amount spent (in $) in Bosnia and Herzegovina in 2008 to that in 2010?
Your answer should be compact. 0.94. What is the ratio of the Amount spent (in $) of Luxembourg in 2008 to that in 2010?
Your response must be concise. 0.91. What is the ratio of the Amount spent (in $) of Macao in 2008 to that in 2010?
Offer a terse response. 1.05. What is the ratio of the Amount spent (in $) in Bosnia and Herzegovina in 2008 to that in 2011?
Your answer should be very brief. 0.88. What is the ratio of the Amount spent (in $) of Luxembourg in 2008 to that in 2011?
Keep it short and to the point. 0.85. What is the ratio of the Amount spent (in $) of Macao in 2008 to that in 2011?
Your answer should be compact. 0.54. What is the ratio of the Amount spent (in $) in Bosnia and Herzegovina in 2009 to that in 2010?
Provide a succinct answer. 0.95. What is the ratio of the Amount spent (in $) of Luxembourg in 2009 to that in 2010?
Keep it short and to the point. 0.97. What is the ratio of the Amount spent (in $) in Macao in 2009 to that in 2010?
Offer a very short reply. 1.1. What is the ratio of the Amount spent (in $) of Bosnia and Herzegovina in 2009 to that in 2011?
Offer a terse response. 0.9. What is the ratio of the Amount spent (in $) in Luxembourg in 2009 to that in 2011?
Make the answer very short. 0.9. What is the ratio of the Amount spent (in $) in Macao in 2009 to that in 2011?
Provide a succinct answer. 0.57. What is the ratio of the Amount spent (in $) of Bosnia and Herzegovina in 2010 to that in 2011?
Ensure brevity in your answer.  0.94. What is the ratio of the Amount spent (in $) of Luxembourg in 2010 to that in 2011?
Your response must be concise. 0.93. What is the ratio of the Amount spent (in $) in Macao in 2010 to that in 2011?
Make the answer very short. 0.52. What is the difference between the highest and the second highest Amount spent (in $) in Bosnia and Herzegovina?
Your answer should be compact. 2.23e+08. What is the difference between the highest and the second highest Amount spent (in $) of Luxembourg?
Provide a succinct answer. 3.47e+08. What is the difference between the highest and the second highest Amount spent (in $) in Macao?
Offer a terse response. 1.32e+08. What is the difference between the highest and the lowest Amount spent (in $) of Bosnia and Herzegovina?
Provide a succinct answer. 2.03e+09. What is the difference between the highest and the lowest Amount spent (in $) in Luxembourg?
Make the answer very short. 1.89e+09. What is the difference between the highest and the lowest Amount spent (in $) in Macao?
Offer a very short reply. 1.99e+08. 